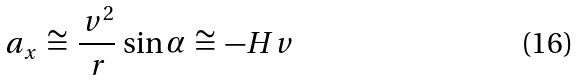<formula> <loc_0><loc_0><loc_500><loc_500>a _ { x } \, \cong \, \frac { \, v ^ { 2 } } { \, r } \, \sin \alpha \, \cong \, - H v</formula> 